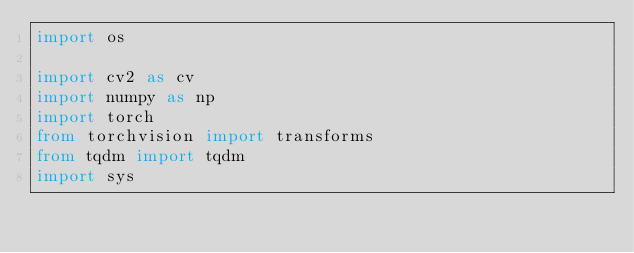Convert code to text. <code><loc_0><loc_0><loc_500><loc_500><_Python_>import os

import cv2 as cv
import numpy as np
import torch
from torchvision import transforms
from tqdm import tqdm
import sys</code> 